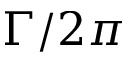Convert formula to latex. <formula><loc_0><loc_0><loc_500><loc_500>\Gamma / 2 \pi</formula> 